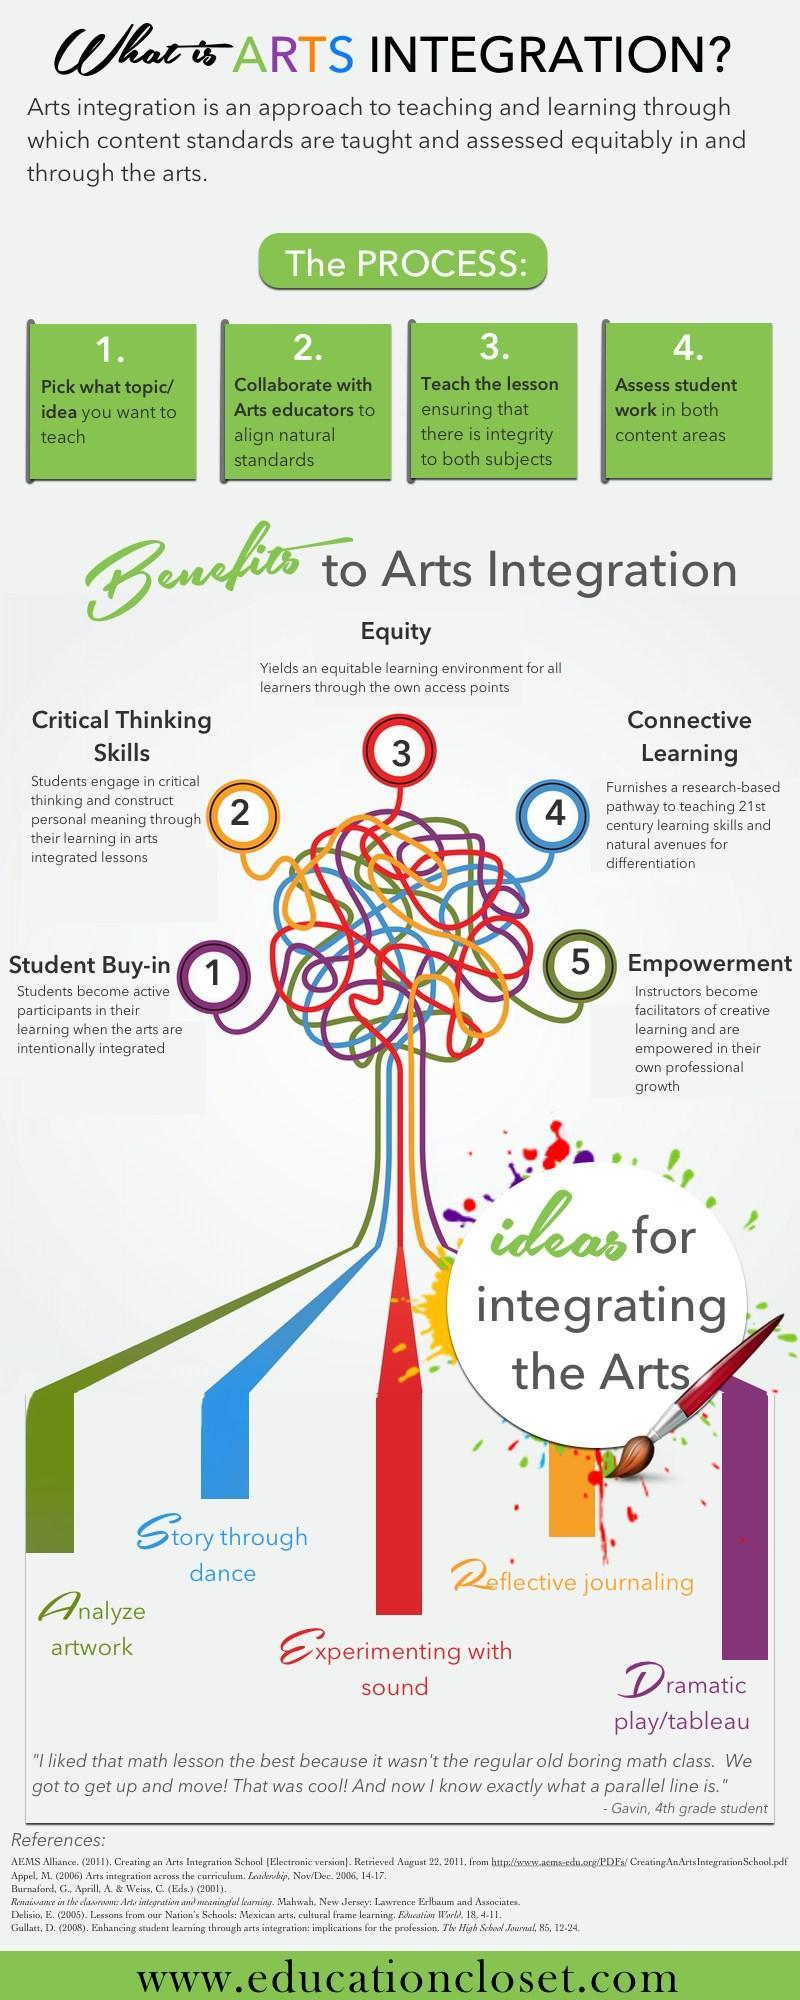What is the benefit derived by educators by analyzing artwork?
Answer the question with a short phrase. Empowerment Which idea or method enables the students to participate actively? Dramatic play/ Tableau Which idea creates an equal learning atmosphere for all learners? Experimenting with sound Which skill of the students does reflective journaling enhance? Critical Thinking Skills What is the benefit derived by students by learning stories through dance? Connective Learning 